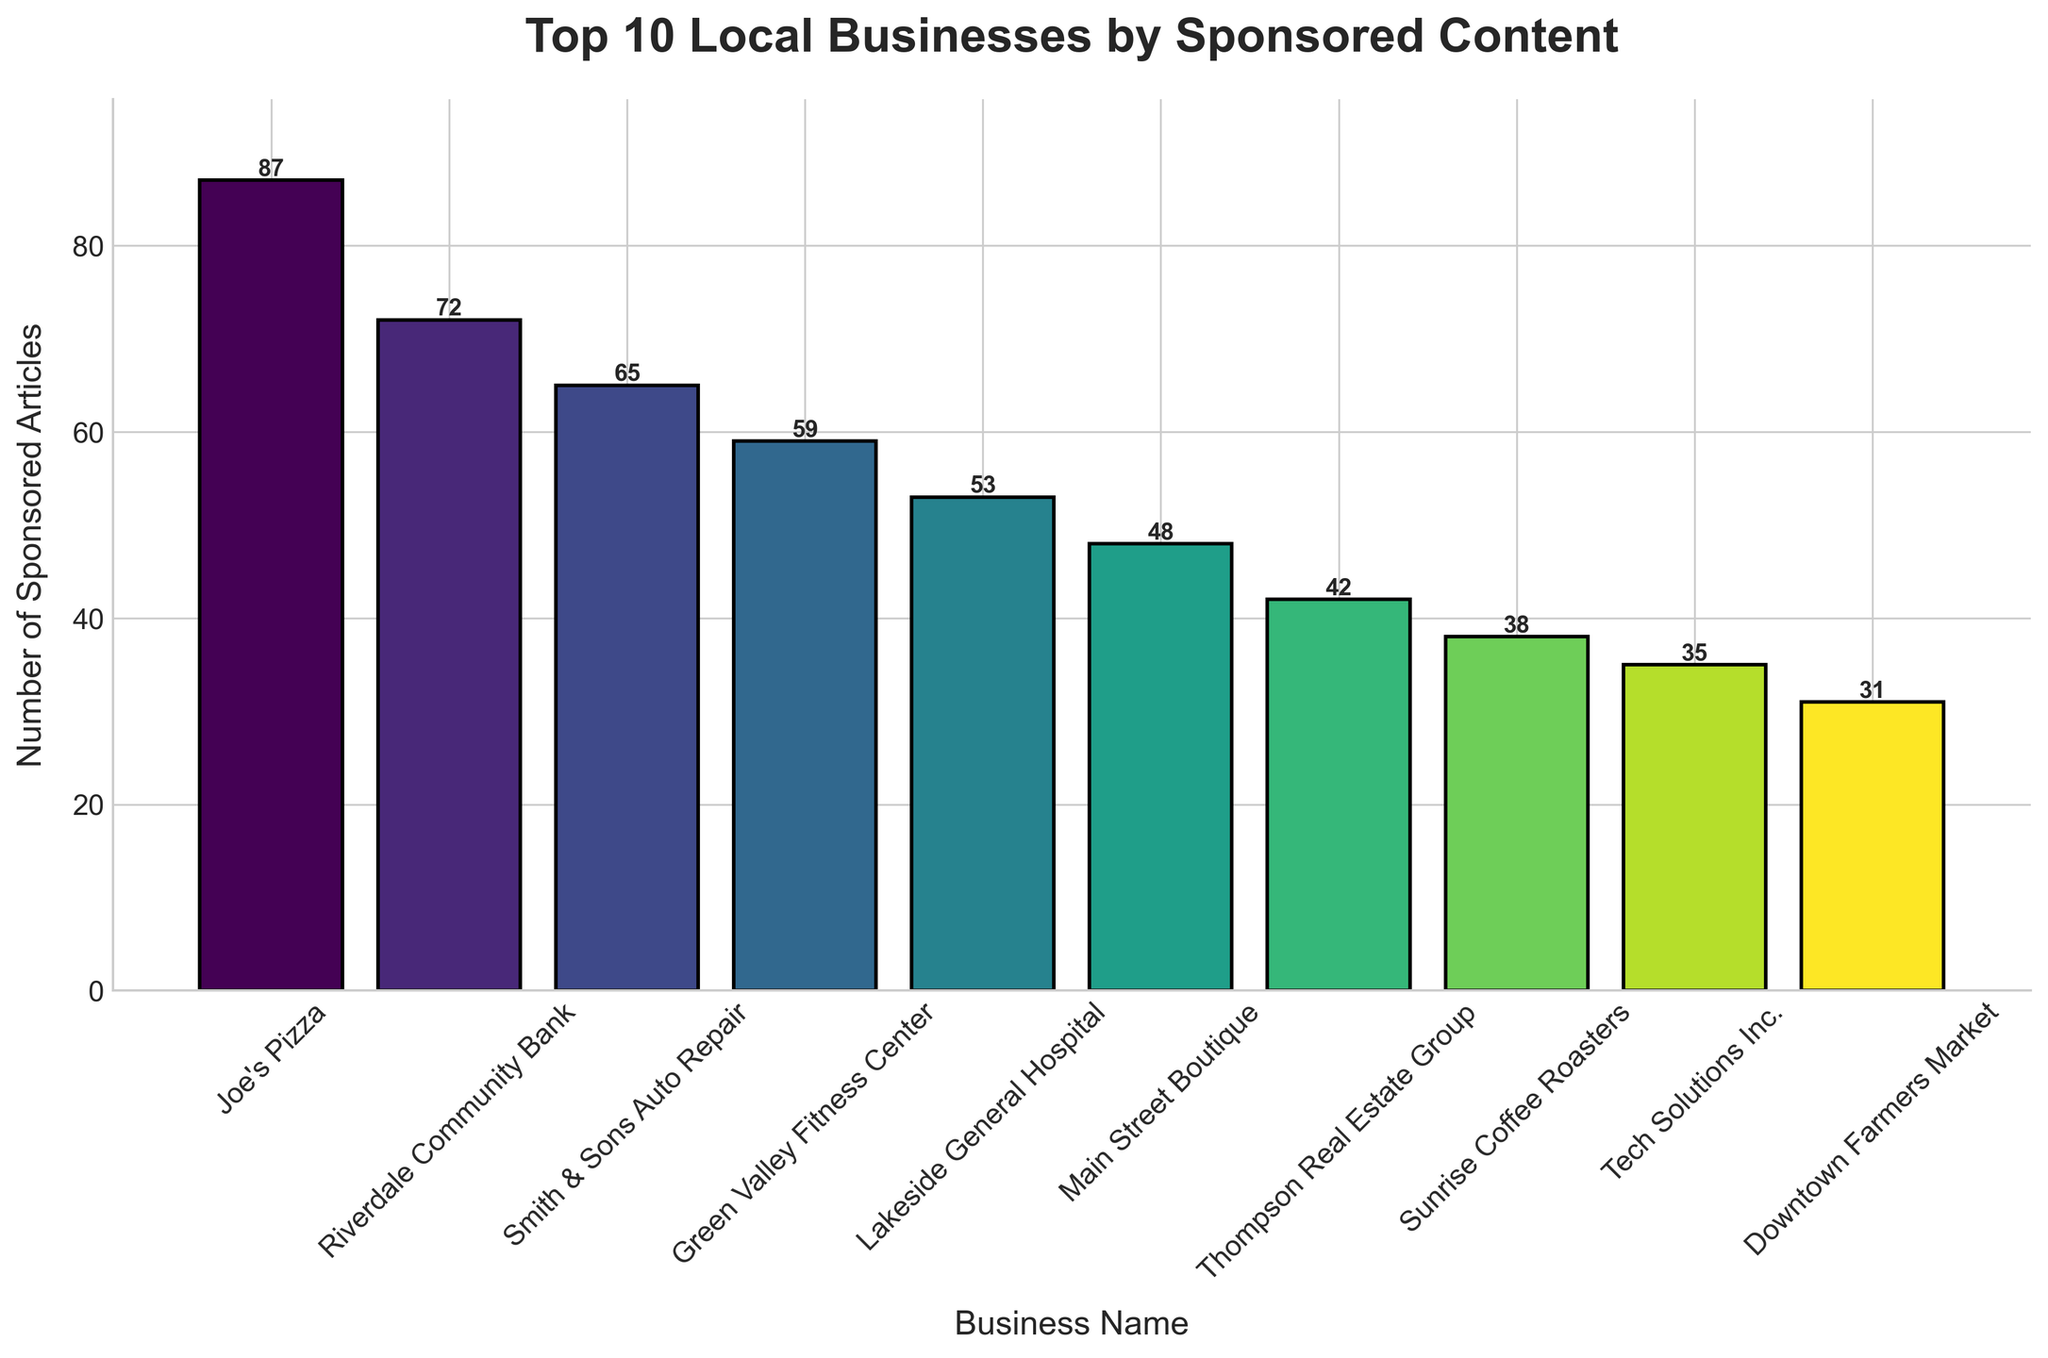Which business has the most sponsored articles? The business with the highest bar has the most sponsored articles. Joe's Pizza has the highest bar.
Answer: Joe's Pizza What is the difference in the number of sponsored articles between Joe's Pizza and Downtown Farmers Market? Joe's Pizza has 87 sponsored articles, and Downtown Farmers Market has 31. Subtract 31 from 87 to find the difference. 87 - 31 = 56.
Answer: 56 On average, how many sponsored articles do the top 10 businesses have? First, sum the number of sponsored articles: 87 + 72 + 65 + 59 + 53 + 48 + 42 + 38 + 35 + 31 = 530. Then, divide by the number of businesses, which is 10. 530 / 10 = 53.
Answer: 53 Which business has the third highest number of sponsored articles? By visually inspecting the heights of the bars, the third highest bar corresponds to Smith & Sons Auto Repair.
Answer: Smith & Sons Auto Repair How many more sponsored articles does Green Valley Fitness Center have compared to Tech Solutions Inc.? Green Valley Fitness Center has 59 sponsored articles, while Tech Solutions Inc. has 35. Subtract 35 from 59. 59 - 35 = 24.
Answer: 24 What is the total number of sponsored articles for the top 5 businesses? Add the number of sponsored articles for Joe's Pizza, Riverdale Community Bank, Smith & Sons Auto Repair, Green Valley Fitness Center, and Lakeside General Hospital: 87 + 72 + 65 + 59 + 53 = 336.
Answer: 336 Which businesses have fewer than 40 sponsored articles? By examining the bars, the businesses with fewer than 40 sponsored articles are Sunrise Coffee Roasters and Downtown Farmers Market.
Answer: Sunrise Coffee Roasters, Downtown Farmers Market What is the sum of sponsored articles for the businesses with the lowest three counts? The businesses with the lowest three counts are Downtown Farmers Market (31), Tech Solutions Inc. (35), and Sunrise Coffee Roasters (38). Add these values: 31 + 35 + 38 = 104.
Answer: 104 Is the number of sponsored articles by Thompson Real Estate Group more or less than the average of the top 10 businesses? The average number of sponsored articles is 53. Thompson Real Estate Group has 42 sponsored articles. 42 is less than 53.
Answer: Less Which business has a slightly higher number of sponsored articles, Lakeside General Hospital or Main Street Boutique? By comparing the heights of the bars, Lakeside General Hospital has 53 sponsored articles, while Main Street Boutique has 48. Thus, Lakeside General Hospital has slightly more.
Answer: Lakeside General Hospital 